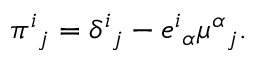<formula> <loc_0><loc_0><loc_500><loc_500>\pi ^ { i _ { j } = \delta ^ { i _ { j } - e ^ { i _ { \alpha } \mu ^ { \alpha _ { j } .</formula> 